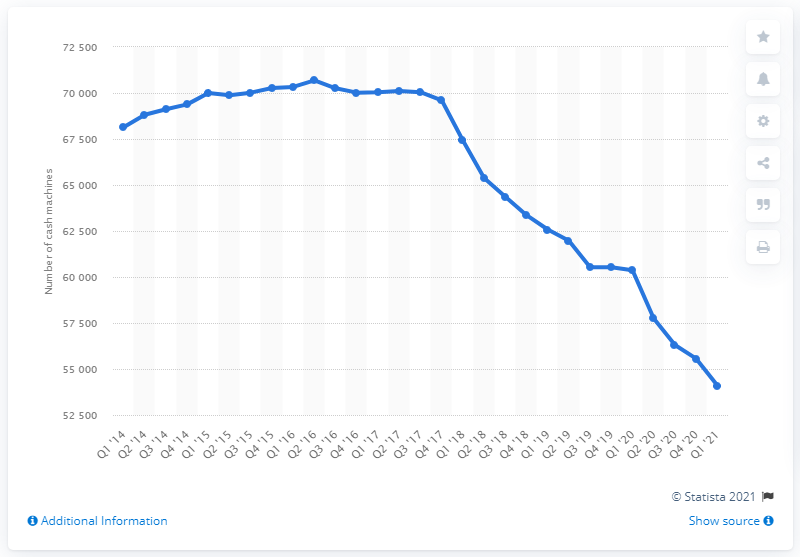Draw attention to some important aspects in this diagram. There were 69,603 ATMs in operation between the first quarter of 2014 and the second quarter of 2016. In the first quarter of 2021, there were approximately 54,099 ATMs in the United Kingdom. 